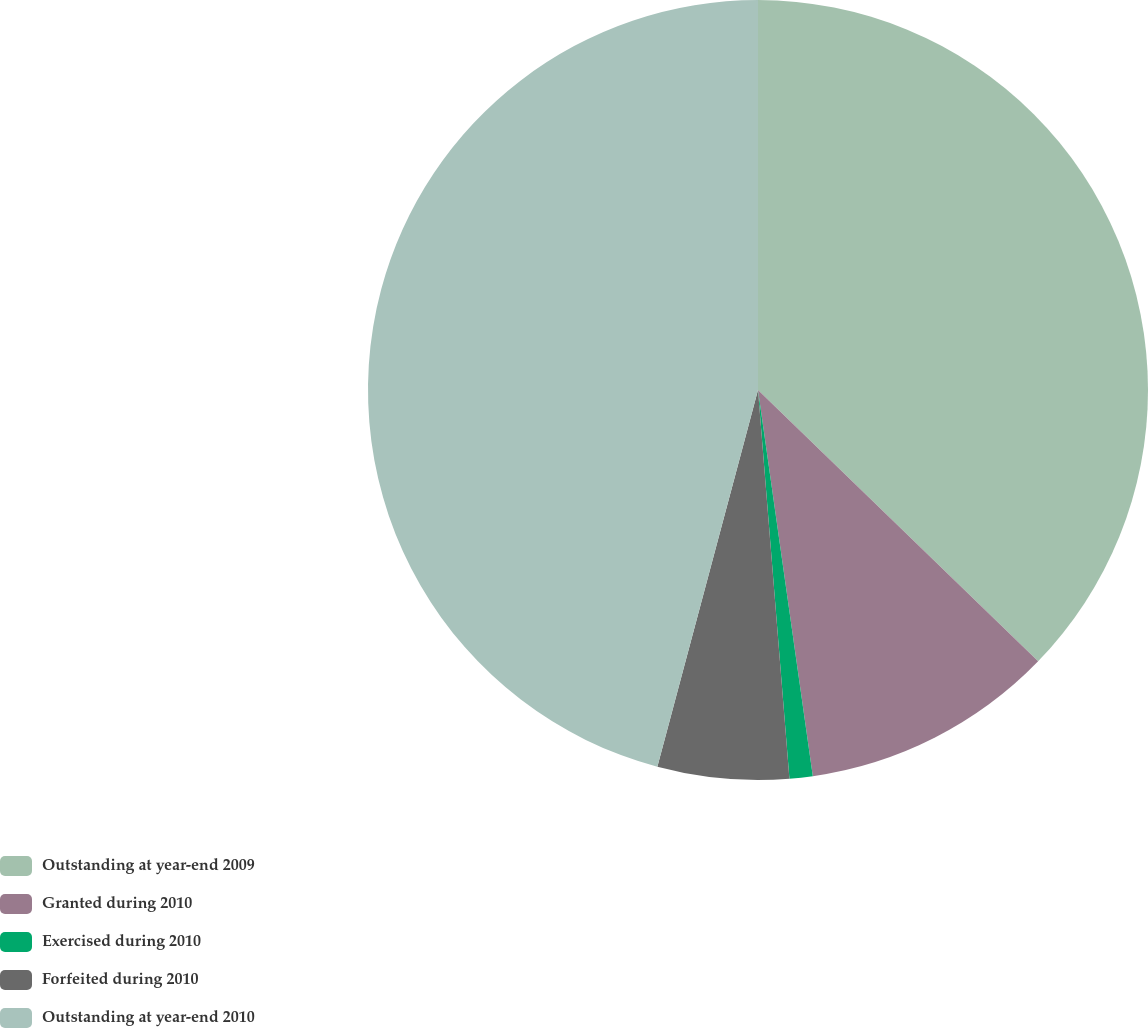Convert chart to OTSL. <chart><loc_0><loc_0><loc_500><loc_500><pie_chart><fcel>Outstanding at year-end 2009<fcel>Granted during 2010<fcel>Exercised during 2010<fcel>Forfeited during 2010<fcel>Outstanding at year-end 2010<nl><fcel>37.25%<fcel>10.51%<fcel>0.96%<fcel>5.44%<fcel>45.85%<nl></chart> 